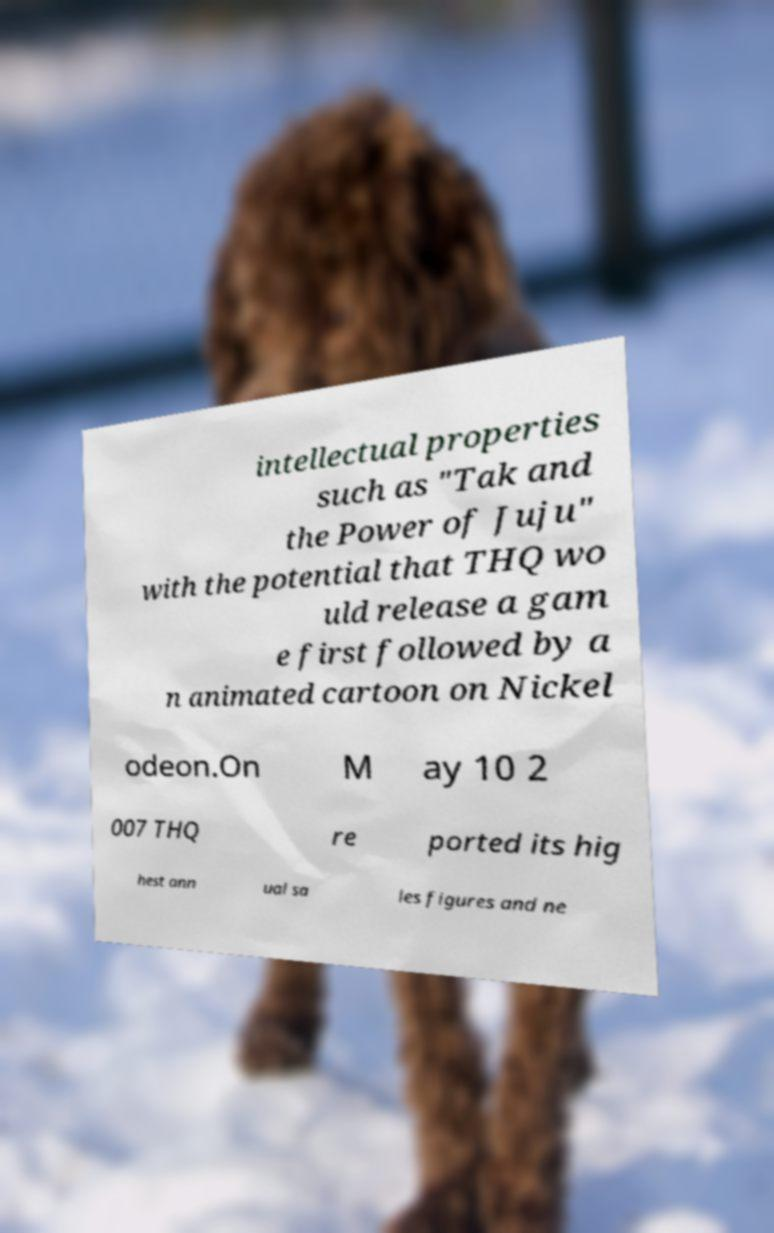There's text embedded in this image that I need extracted. Can you transcribe it verbatim? intellectual properties such as "Tak and the Power of Juju" with the potential that THQ wo uld release a gam e first followed by a n animated cartoon on Nickel odeon.On M ay 10 2 007 THQ re ported its hig hest ann ual sa les figures and ne 